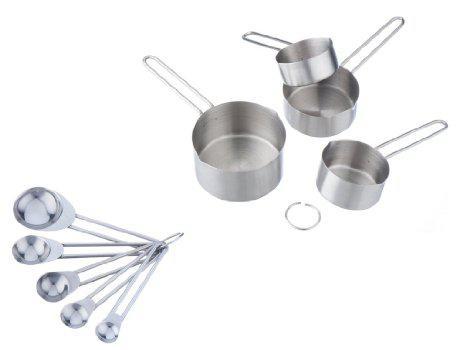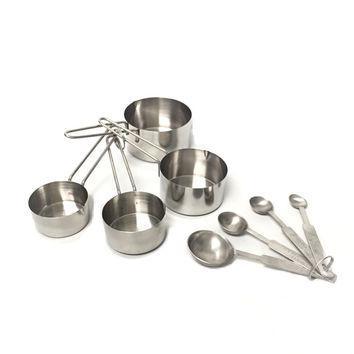The first image is the image on the left, the second image is the image on the right. Analyze the images presented: Is the assertion "An image features only a joined group of exactly four measuring cups." valid? Answer yes or no. No. 